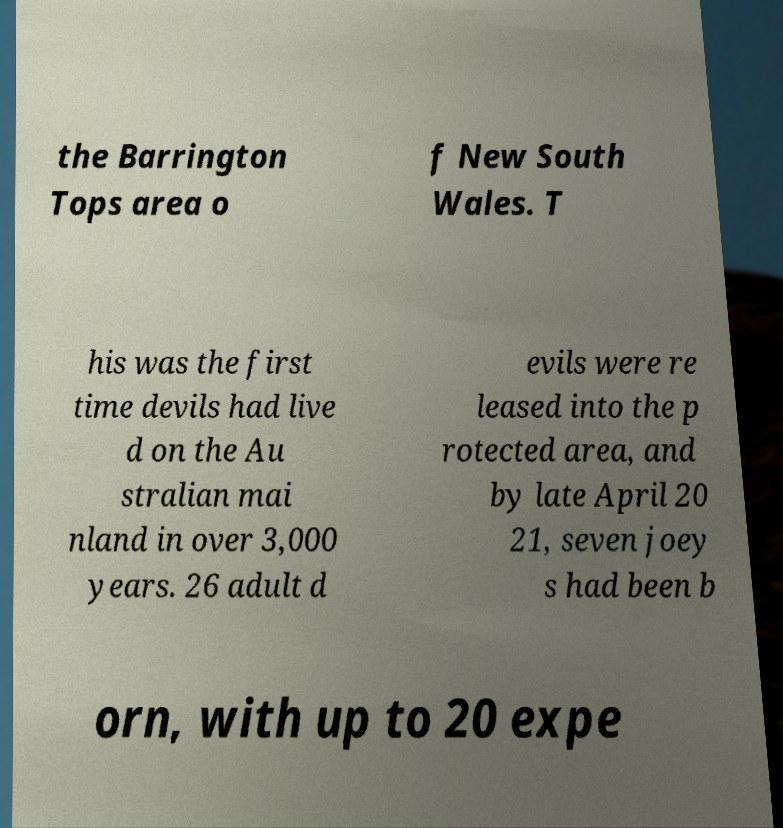I need the written content from this picture converted into text. Can you do that? the Barrington Tops area o f New South Wales. T his was the first time devils had live d on the Au stralian mai nland in over 3,000 years. 26 adult d evils were re leased into the p rotected area, and by late April 20 21, seven joey s had been b orn, with up to 20 expe 